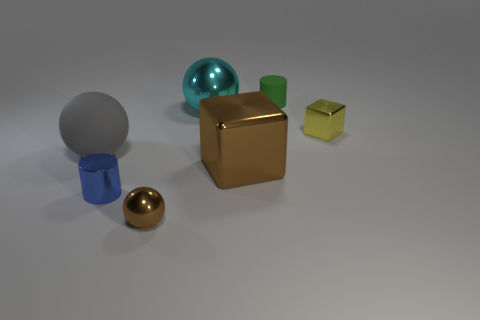There is a big matte object that is on the left side of the tiny green thing; is it the same shape as the green matte object?
Keep it short and to the point. No. What number of tiny things are both to the right of the small green thing and in front of the small blue cylinder?
Ensure brevity in your answer.  0. What is the blue object made of?
Give a very brief answer. Metal. Are there any other things that have the same color as the small metallic sphere?
Provide a short and direct response. Yes. Is the material of the brown sphere the same as the green object?
Your answer should be compact. No. There is a cylinder behind the large shiny thing in front of the small yellow metal thing; how many tiny shiny things are to the left of it?
Your answer should be compact. 2. How many small shiny cylinders are there?
Your answer should be very brief. 1. Is the number of large cyan metallic objects that are in front of the small blue metal cylinder less than the number of cyan metallic objects behind the large matte ball?
Provide a succinct answer. Yes. Is the number of tiny cylinders that are in front of the brown metallic ball less than the number of metallic cubes?
Offer a terse response. Yes. There is a cube to the right of the matte thing that is right of the metallic ball that is in front of the large brown metallic cube; what is it made of?
Give a very brief answer. Metal. 